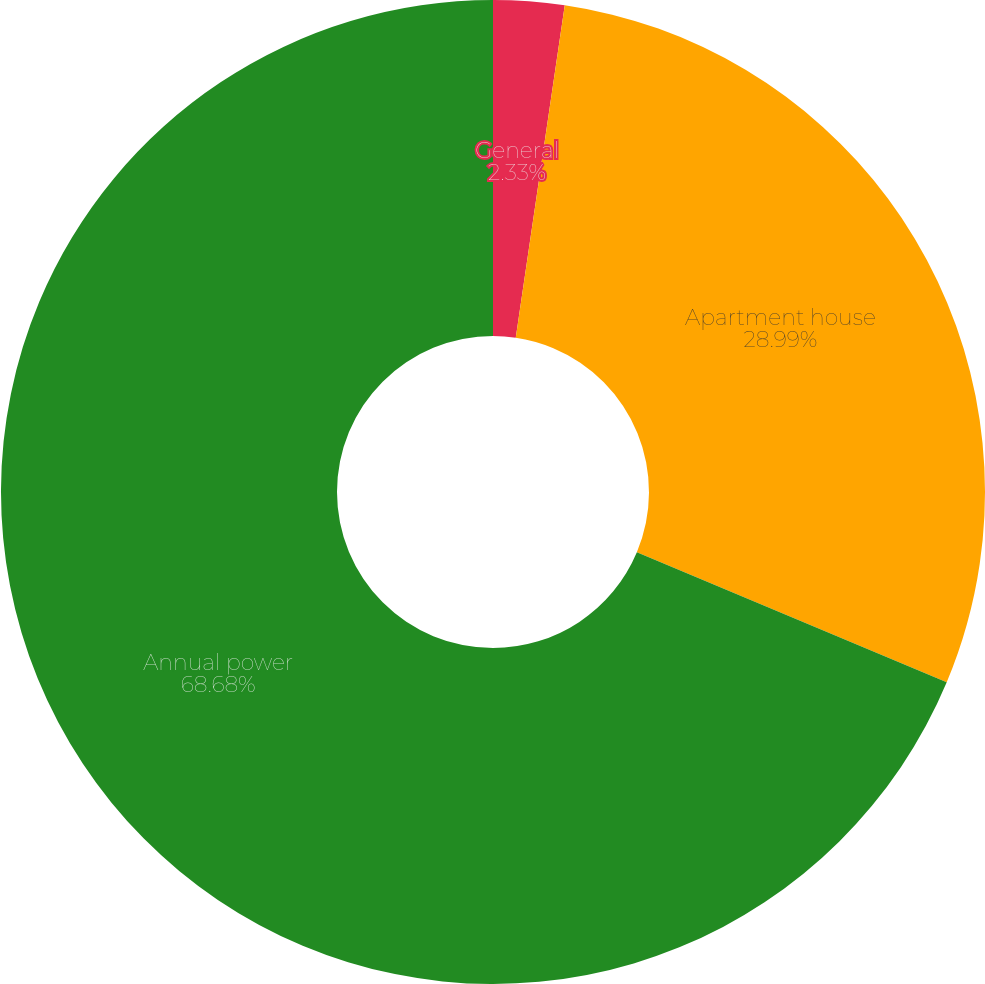Convert chart to OTSL. <chart><loc_0><loc_0><loc_500><loc_500><pie_chart><fcel>General<fcel>Apartment house<fcel>Annual power<nl><fcel>2.33%<fcel>28.99%<fcel>68.68%<nl></chart> 